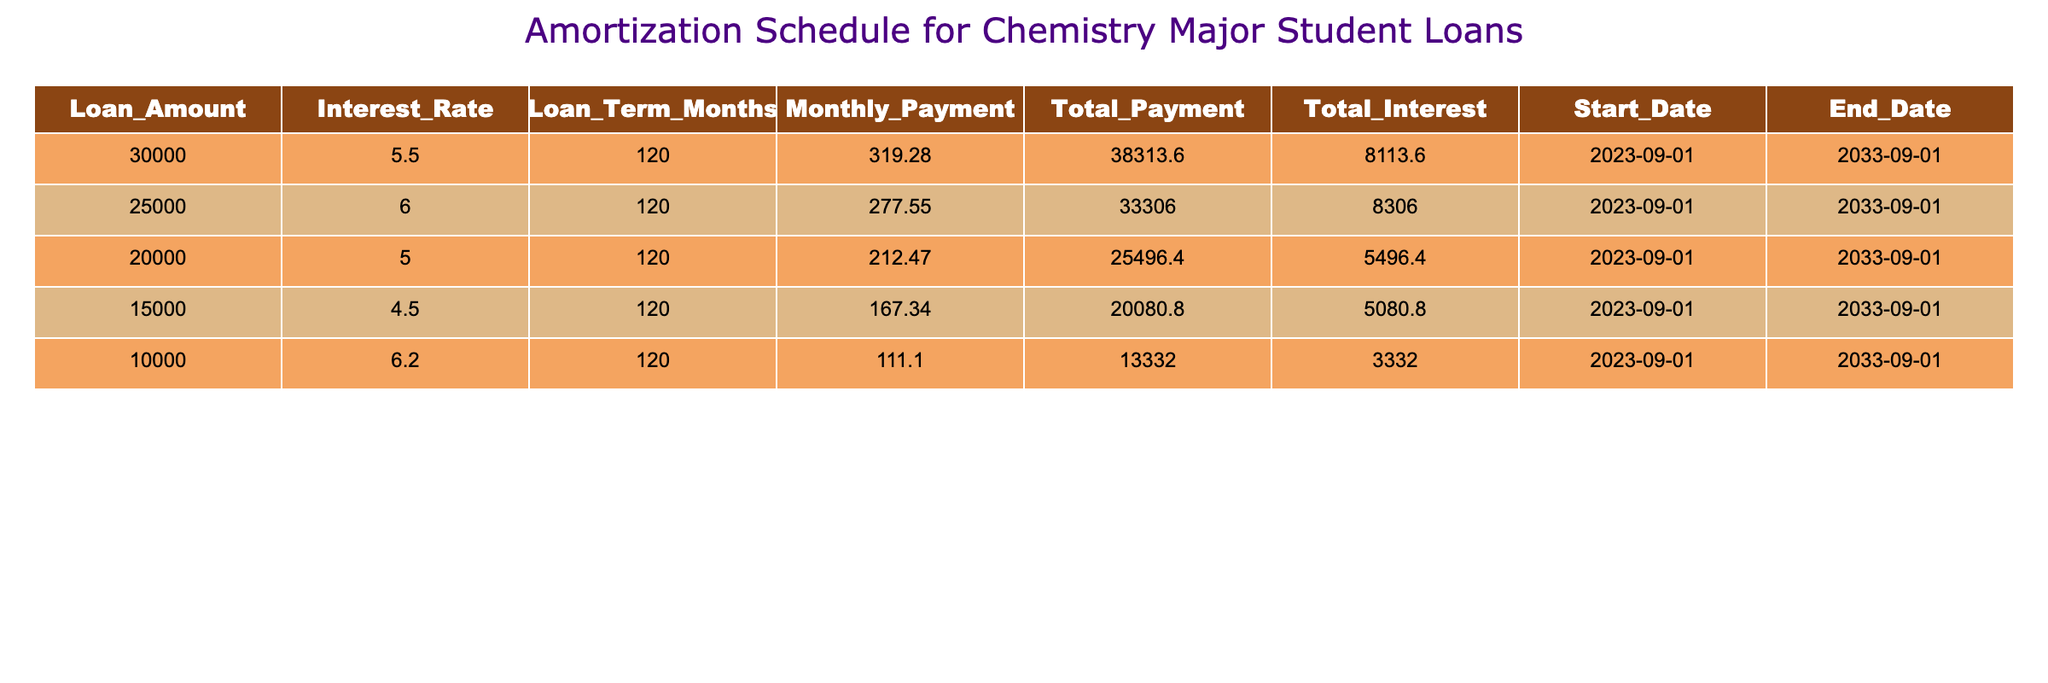What is the loan amount with the highest total interest? The total interest for each loan amount is as follows: 8113.60, 8306.00, 5496.40, 5080.80, and 3332.00. The highest value among these is 8306.00, which corresponds to the loan amount of 25000.
Answer: 25000 What is the total payment for the loan with the lowest monthly payment? The monthly payments for each loan amount are: 319.28, 277.55, 212.47, 167.34, and 111.10. The lowest monthly payment is 111.10, which corresponds to the loan amount of 10000. The total payment for this loan is 13332.00.
Answer: 13332.00 What is the average interest rate of all loans? The interest rates are 5.5, 6.0, 5.0, 4.5, and 6.2. To find the average, sum these values (5.5 + 6.0 + 5.0 + 4.5 + 6.2) = 27.2 and then divide by the number of loans (5), yielding an average of 27.2 / 5 = 5.44.
Answer: 5.44 Is the total interest for the loan amount of 30000 greater than the total interest for the loan amount of 15000? The total interest for the loan amount of 30000 is 8113.60, and for 15000, it is 5080.80. Comparing these, 8113.60 is greater than 5080.80.
Answer: Yes Which loan has the longest loan term? All loans have the same loan term of 120 months, hence there is no variation in terms.
Answer: 120 months 